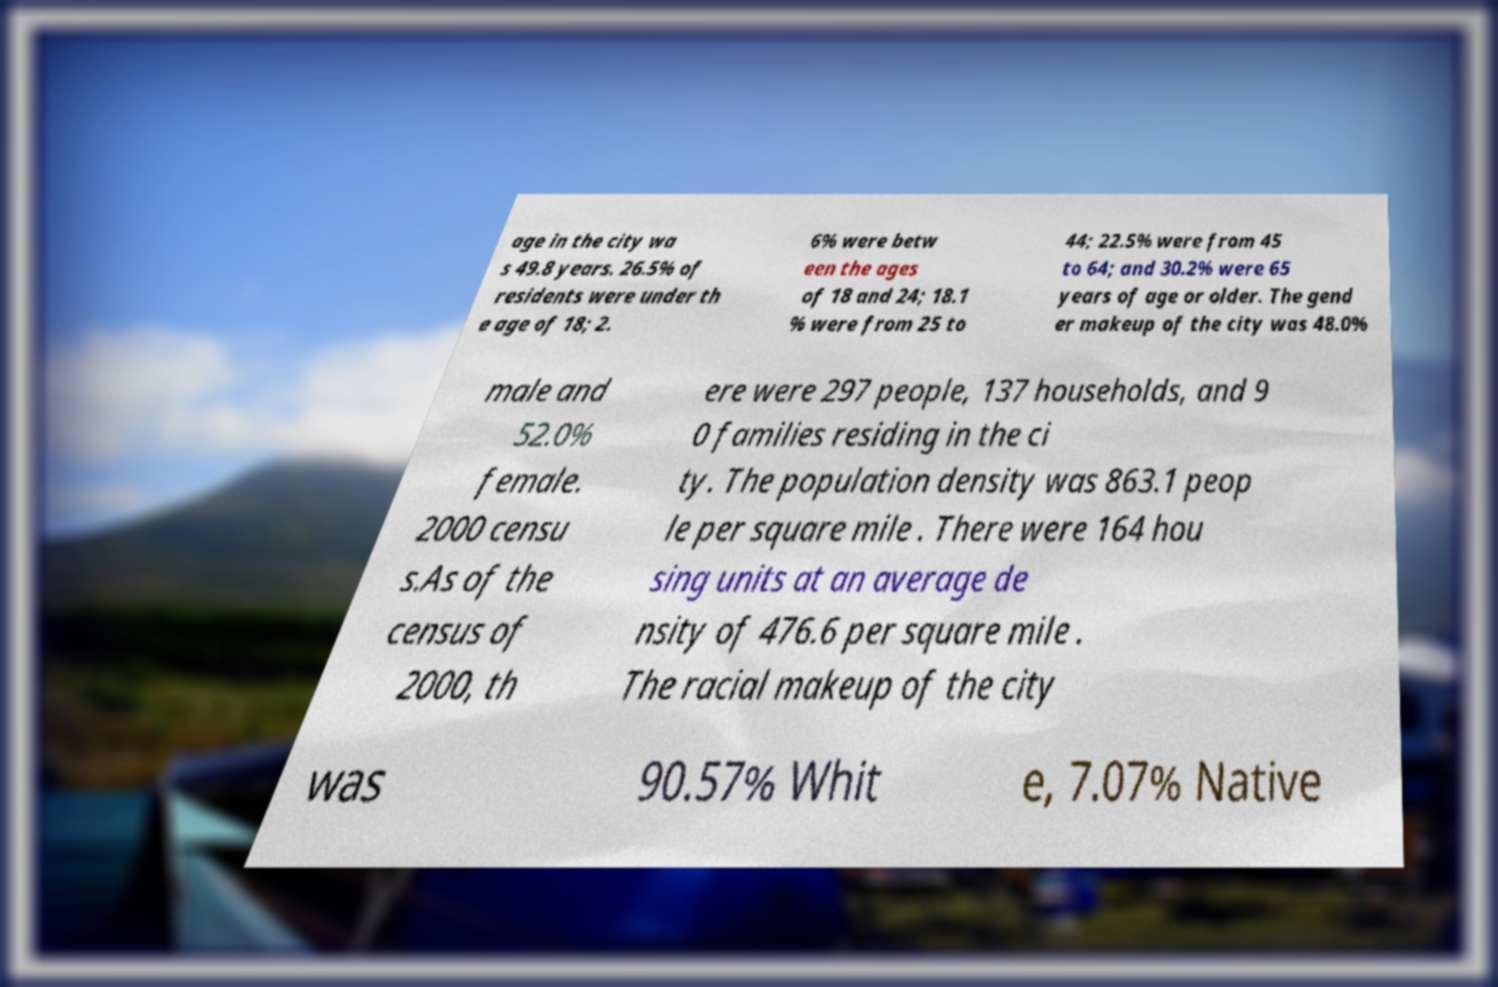Please read and relay the text visible in this image. What does it say? age in the city wa s 49.8 years. 26.5% of residents were under th e age of 18; 2. 6% were betw een the ages of 18 and 24; 18.1 % were from 25 to 44; 22.5% were from 45 to 64; and 30.2% were 65 years of age or older. The gend er makeup of the city was 48.0% male and 52.0% female. 2000 censu s.As of the census of 2000, th ere were 297 people, 137 households, and 9 0 families residing in the ci ty. The population density was 863.1 peop le per square mile . There were 164 hou sing units at an average de nsity of 476.6 per square mile . The racial makeup of the city was 90.57% Whit e, 7.07% Native 